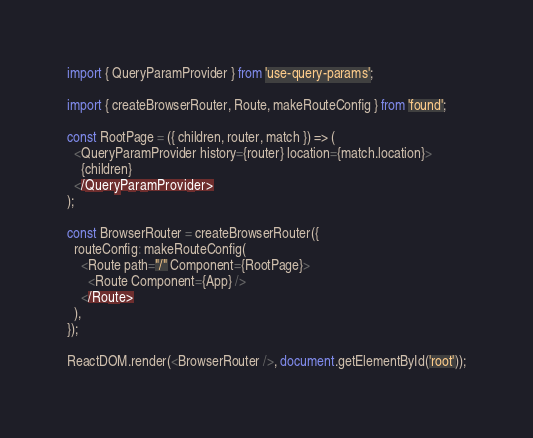<code> <loc_0><loc_0><loc_500><loc_500><_JavaScript_>import { QueryParamProvider } from 'use-query-params';

import { createBrowserRouter, Route, makeRouteConfig } from 'found';

const RootPage = ({ children, router, match }) => (
  <QueryParamProvider history={router} location={match.location}>
    {children}
  </QueryParamProvider>
);

const BrowserRouter = createBrowserRouter({
  routeConfig: makeRouteConfig(
    <Route path="/" Component={RootPage}>
      <Route Component={App} />
    </Route>
  ),
});

ReactDOM.render(<BrowserRouter />, document.getElementById('root'));
</code> 